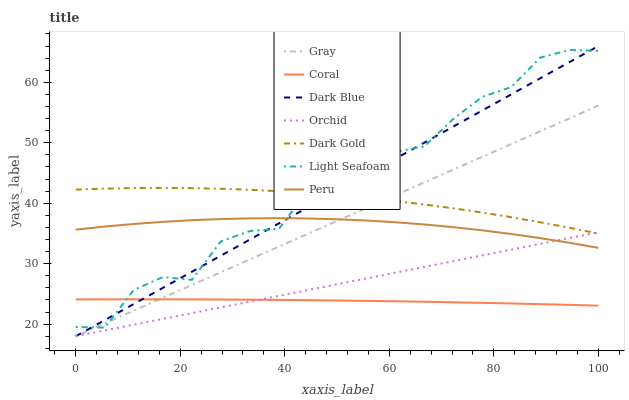Does Coral have the minimum area under the curve?
Answer yes or no. Yes. Does Light Seafoam have the maximum area under the curve?
Answer yes or no. Yes. Does Dark Gold have the minimum area under the curve?
Answer yes or no. No. Does Dark Gold have the maximum area under the curve?
Answer yes or no. No. Is Orchid the smoothest?
Answer yes or no. Yes. Is Light Seafoam the roughest?
Answer yes or no. Yes. Is Dark Gold the smoothest?
Answer yes or no. No. Is Dark Gold the roughest?
Answer yes or no. No. Does Gray have the lowest value?
Answer yes or no. Yes. Does Coral have the lowest value?
Answer yes or no. No. Does Dark Blue have the highest value?
Answer yes or no. Yes. Does Dark Gold have the highest value?
Answer yes or no. No. Is Peru less than Dark Gold?
Answer yes or no. Yes. Is Light Seafoam greater than Orchid?
Answer yes or no. Yes. Does Coral intersect Gray?
Answer yes or no. Yes. Is Coral less than Gray?
Answer yes or no. No. Is Coral greater than Gray?
Answer yes or no. No. Does Peru intersect Dark Gold?
Answer yes or no. No. 